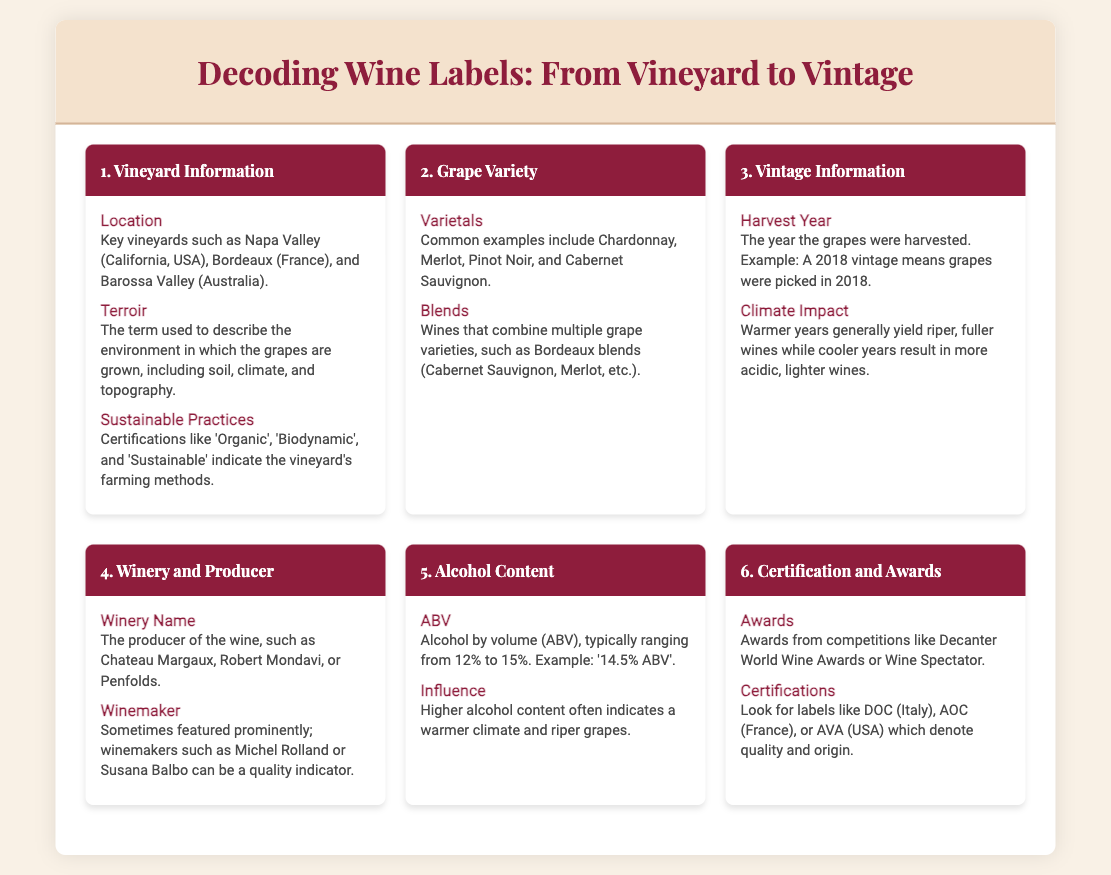What are some key vineyard locations mentioned? The document lists key vineyard locations such as Napa Valley, Bordeaux, and Barossa Valley under the Vineyard Information section.
Answer: Napa Valley, Bordeaux, Barossa Valley What term describes the environment where grapes are grown? The term "terroir" is used to describe the environment in which the grapes are grown, including soil, climate, and topography.
Answer: Terroir Name a common grape varietal. The document lists several grape varietals, including Chardonnay, Merlot, and Pinot Noir.
Answer: Chardonnay What does the vintage year indicate? The vintage year, such as 2018, indicates the year the grapes were harvested.
Answer: 2018 What does ABV stand for? ABV stands for "Alcohol by volume," which indicates the alcohol content in the wine.
Answer: Alcohol by volume Which certification indicates organic farming practices? The document mentions "Organic" as one of the certifications that indicate sustainable farming practices.
Answer: Organic What is a characteristic of warmer vintage years? Warmer vintage years generally yield riper, fuller wines.
Answer: Riper, fuller wines What is the significance of winery name on a label? The winery name indicates the producer of the wine, which can suggest quality.
Answer: Producer of the wine What phrase is associated with wine blends? The document mentions that blends combine multiple grape varieties, referring specifically to Bordeaux blends.
Answer: Bordeaux blends 